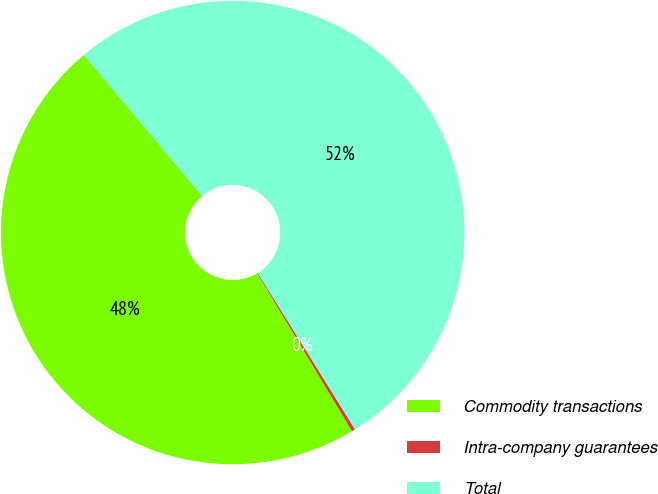Convert chart to OTSL. <chart><loc_0><loc_0><loc_500><loc_500><pie_chart><fcel>Commodity transactions<fcel>Intra-company guarantees<fcel>Total<nl><fcel>47.5%<fcel>0.24%<fcel>52.25%<nl></chart> 